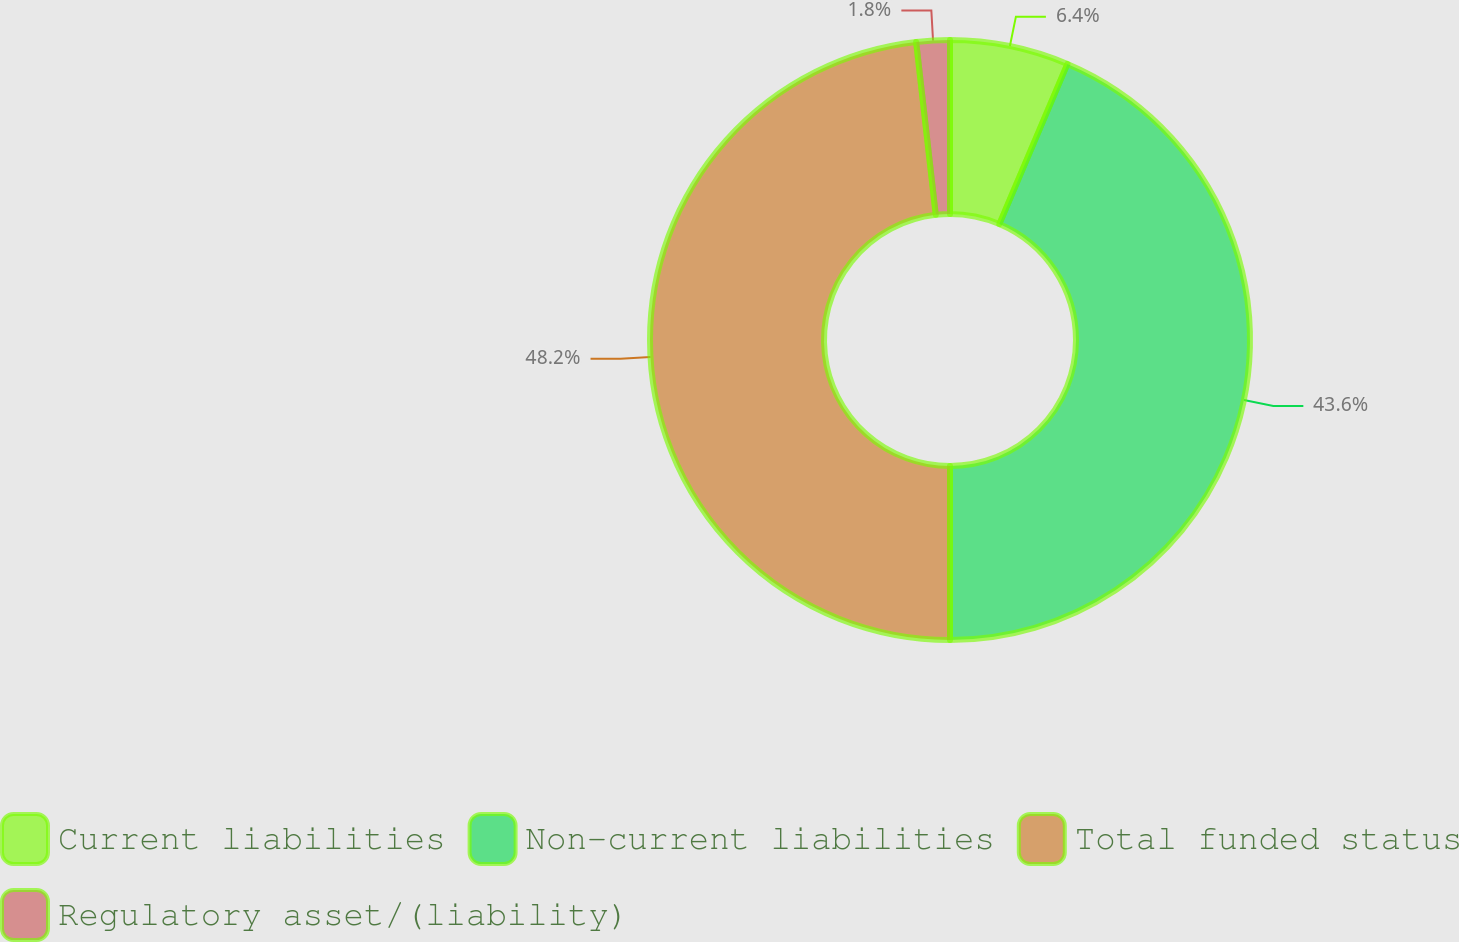Convert chart to OTSL. <chart><loc_0><loc_0><loc_500><loc_500><pie_chart><fcel>Current liabilities<fcel>Non-current liabilities<fcel>Total funded status<fcel>Regulatory asset/(liability)<nl><fcel>6.4%<fcel>43.6%<fcel>48.2%<fcel>1.8%<nl></chart> 